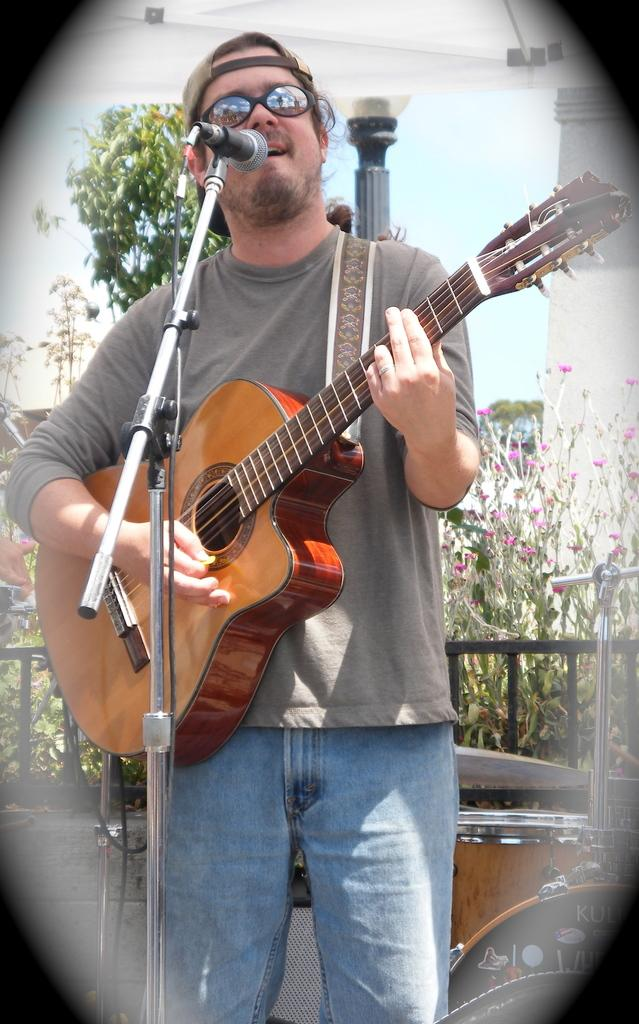What is the person in the image doing? The person is playing a guitar and singing in front of a microphone. What type of object is the person using to amplify their voice? The person is using a microphone with a holder. What can be seen in the background of the image? There is a tree visible in the image. What is the guitar used for in the image? The guitar is a musical instrument being played by the person. What type of stamp can be seen on the person's hand in the image? There is no stamp visible on the person's hand in the image. What time of day is it in the image? The time of day cannot be determined from the image alone, as there are no specific clues or indicators. 